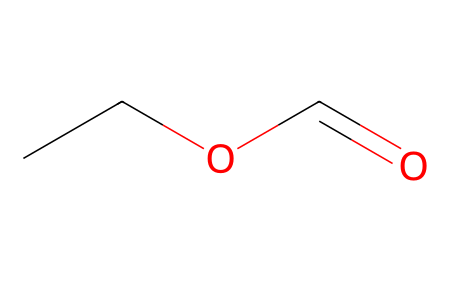What is the molecular formula of ethyl formate? By analyzing the SMILES representation "CCOC=O", we can identify the components: "CC" indicates two carbon atoms from ethyl, "O" signifies an oxygen atom, and "C=O" indicates another carbon attached to an oxygen that signifies the carbonyl component of the ester group. Thus, the compound includes 3 carbon atoms (C), 6 hydrogen atoms (H), and 2 oxygen atoms (O), leading to the molecular formula C3H6O2.
Answer: C3H6O2 How many carbon atoms are present in ethyl formate? In the SMILES "CCOC=O", each "C" represents a carbon atom. There are three "C" characters present ('CC' and 'C=O'), indicating that there are 3 carbon atoms in total.
Answer: 3 What type of functional group is present in ethyl formate? The structure "CCOC=O" displays an ester functional group characterized by the presence of a carbonyl (C=O) connected to an ether part (R-O-R). This indicates that ethyl formate contains an ester functional group.
Answer: ester What is the ratio of hydrogen to carbon atoms in ethyl formate? Considering the molecular formula derived (C3H6O2), there are 6 hydrogen atoms and 3 carbon atoms. To find the ratio, we divide the number of hydrogen atoms (6) by the number of carbon atoms (3), yielding a ratio of 2:1.
Answer: 2:1 Does ethyl formate have any oxygen atoms? Observing the SMILES "CCOC=O", there are two instances of "O" within the structure, confirming that there are indeed oxygen atoms present in ethyl formate.
Answer: yes 